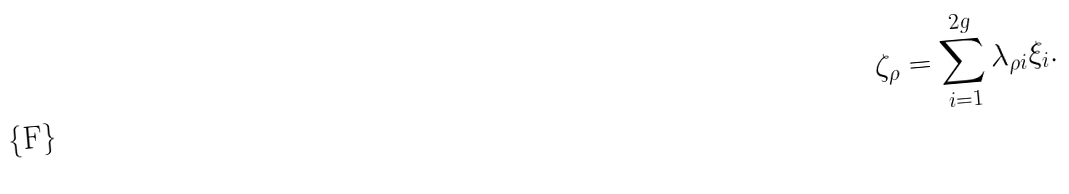Convert formula to latex. <formula><loc_0><loc_0><loc_500><loc_500>\zeta _ { \rho } = \sum _ { i = 1 } ^ { 2 g } \lambda _ { \rho i } \xi _ { i } .</formula> 